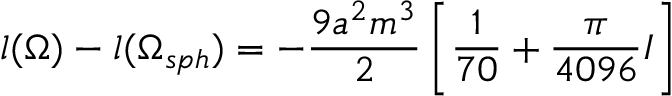<formula> <loc_0><loc_0><loc_500><loc_500>l ( \Omega ) - l ( \Omega _ { s p h } ) = - \frac { 9 a ^ { 2 } m ^ { 3 } } { 2 } \left [ \frac { 1 } { 7 0 } + \frac { \pi } { 4 0 9 6 } I \right ]</formula> 